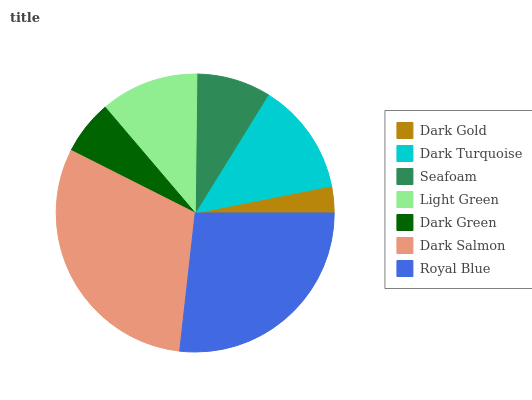Is Dark Gold the minimum?
Answer yes or no. Yes. Is Dark Salmon the maximum?
Answer yes or no. Yes. Is Dark Turquoise the minimum?
Answer yes or no. No. Is Dark Turquoise the maximum?
Answer yes or no. No. Is Dark Turquoise greater than Dark Gold?
Answer yes or no. Yes. Is Dark Gold less than Dark Turquoise?
Answer yes or no. Yes. Is Dark Gold greater than Dark Turquoise?
Answer yes or no. No. Is Dark Turquoise less than Dark Gold?
Answer yes or no. No. Is Light Green the high median?
Answer yes or no. Yes. Is Light Green the low median?
Answer yes or no. Yes. Is Dark Salmon the high median?
Answer yes or no. No. Is Dark Turquoise the low median?
Answer yes or no. No. 